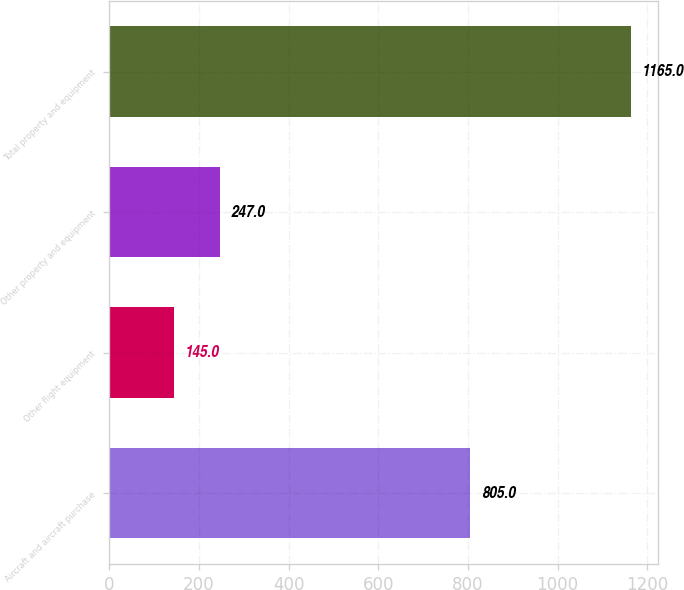Convert chart to OTSL. <chart><loc_0><loc_0><loc_500><loc_500><bar_chart><fcel>Aircraft and aircraft purchase<fcel>Other flight equipment<fcel>Other property and equipment<fcel>Total property and equipment<nl><fcel>805<fcel>145<fcel>247<fcel>1165<nl></chart> 